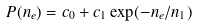<formula> <loc_0><loc_0><loc_500><loc_500>P ( n _ { e } ) = c _ { 0 } + c _ { 1 } \exp ( - n _ { e } / n _ { 1 } )</formula> 